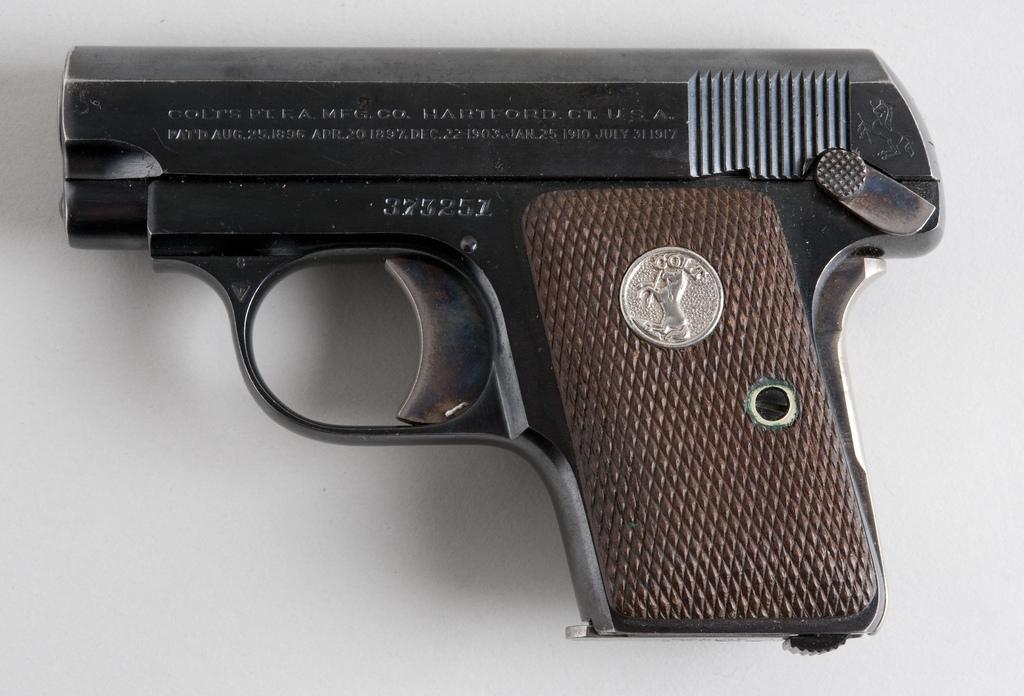What colors are present on the gun in the image? The gun is in black and brown colors. What type of hope can be seen growing in the alley next to the gun? There is no alley or hope present in the image; it only features a gun in black and brown colors. 